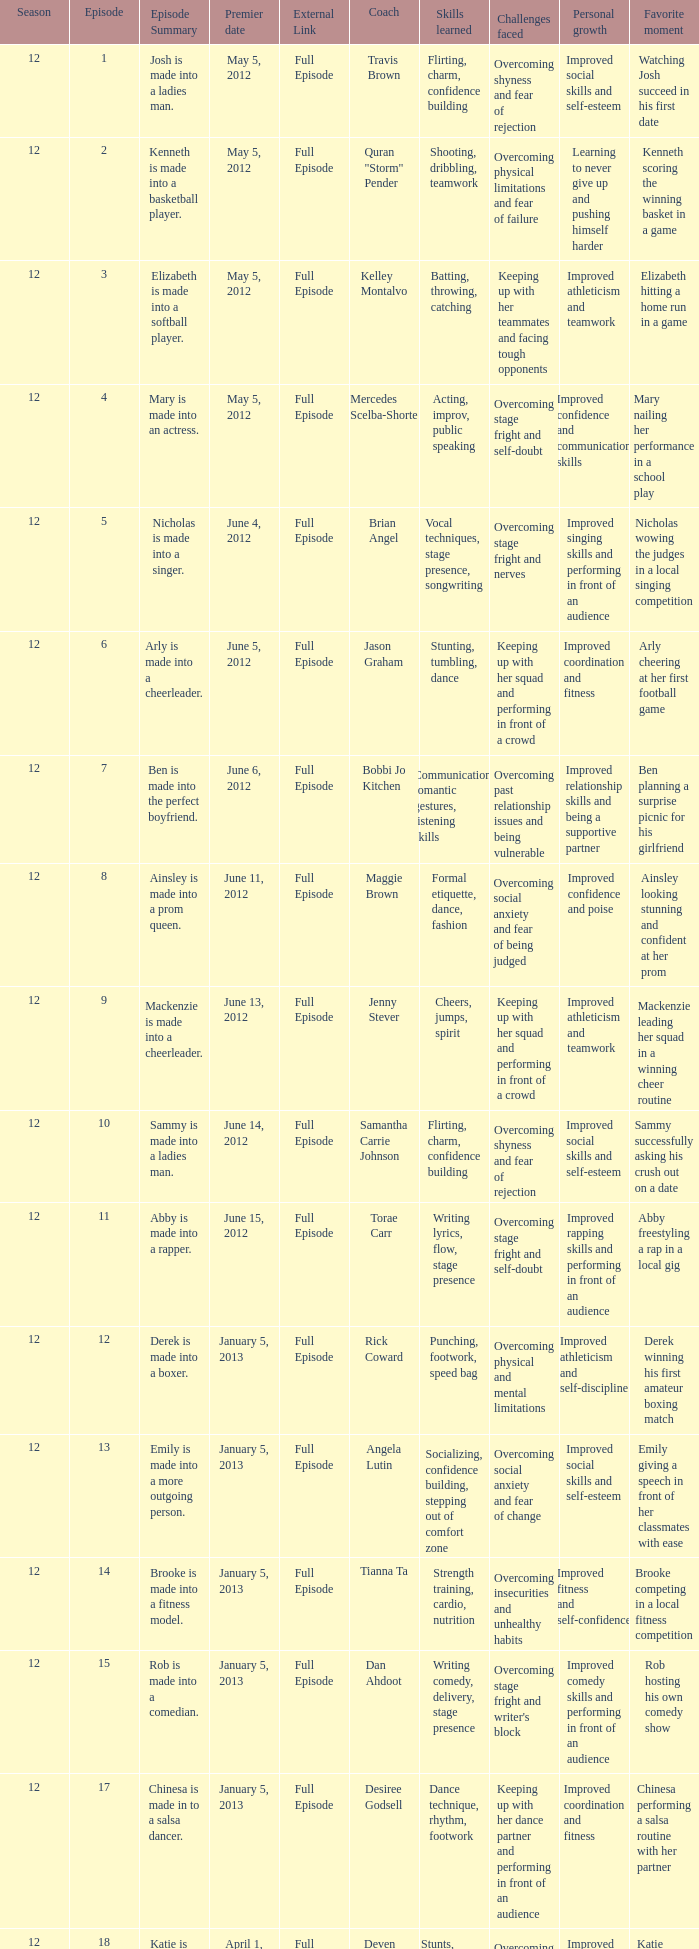Name the coach for  emily is made into a more outgoing person. Angela Lutin. 